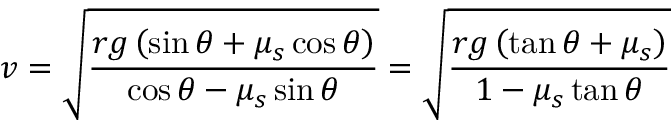<formula> <loc_0><loc_0><loc_500><loc_500>v = { \sqrt { \frac { r g \left ( \sin \theta + \mu _ { s } \cos \theta \right ) } { \cos \theta - \mu _ { s } \sin \theta } } } = { \sqrt { \frac { r g \left ( \tan \theta + \mu _ { s } \right ) } { 1 - \mu _ { s } \tan \theta } } }</formula> 